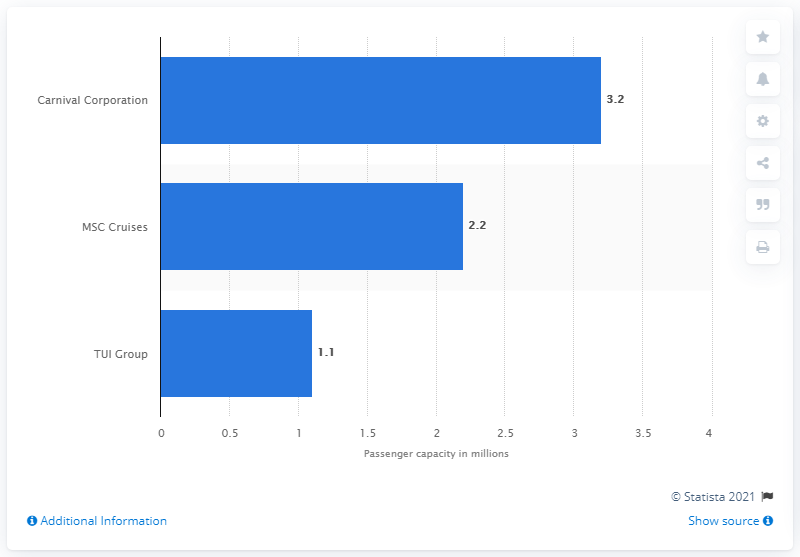Point out several critical features in this image. Carnival Corporation had the largest combined passenger capacity among all cruise lines in 2021. In 2019, MSC Cruises had a total of 2,200 passengers. 